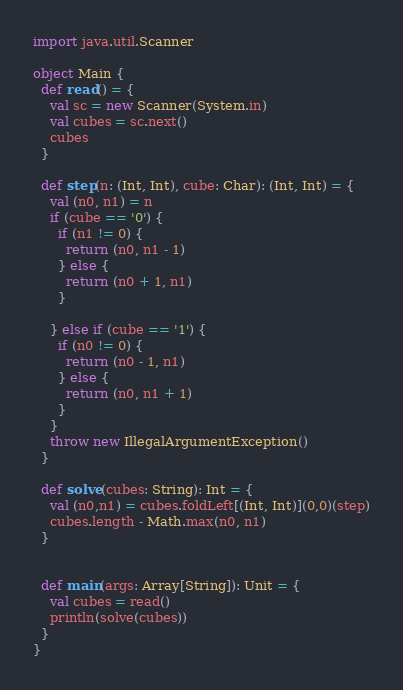Convert code to text. <code><loc_0><loc_0><loc_500><loc_500><_Scala_>import java.util.Scanner

object Main {
  def read() = {
    val sc = new Scanner(System.in)
    val cubes = sc.next()
    cubes
  }

  def step(n: (Int, Int), cube: Char): (Int, Int) = {
    val (n0, n1) = n
    if (cube == '0') {
      if (n1 != 0) {
        return (n0, n1 - 1)
      } else {
        return (n0 + 1, n1)
      }

    } else if (cube == '1') {
      if (n0 != 0) {
        return (n0 - 1, n1)
      } else {
        return (n0, n1 + 1)
      }
    }
    throw new IllegalArgumentException()
  }

  def solve(cubes: String): Int = {
    val (n0,n1) = cubes.foldLeft[(Int, Int)](0,0)(step)
    cubes.length - Math.max(n0, n1)
  }


  def main(args: Array[String]): Unit = {
    val cubes = read()
    println(solve(cubes))
  }
}</code> 